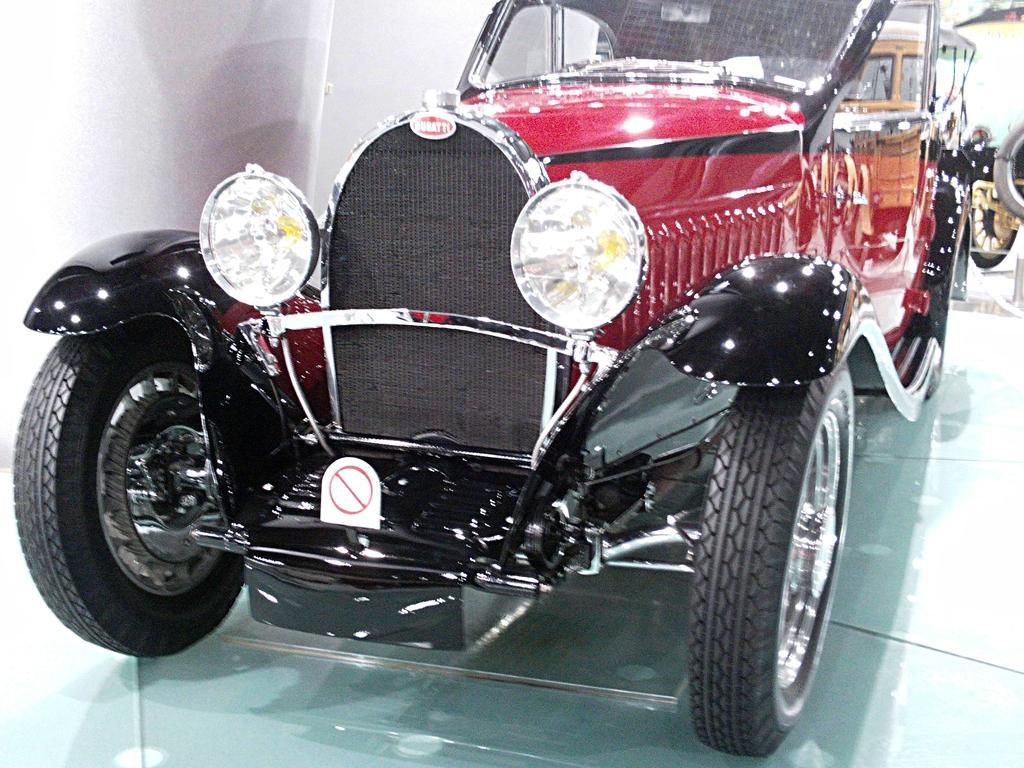Describe this image in one or two sentences. In this image I can see the vehicle which is in black and red color. It on the glass surface. In the background I can see few more vehicles. To the left I can see the white color wall. 